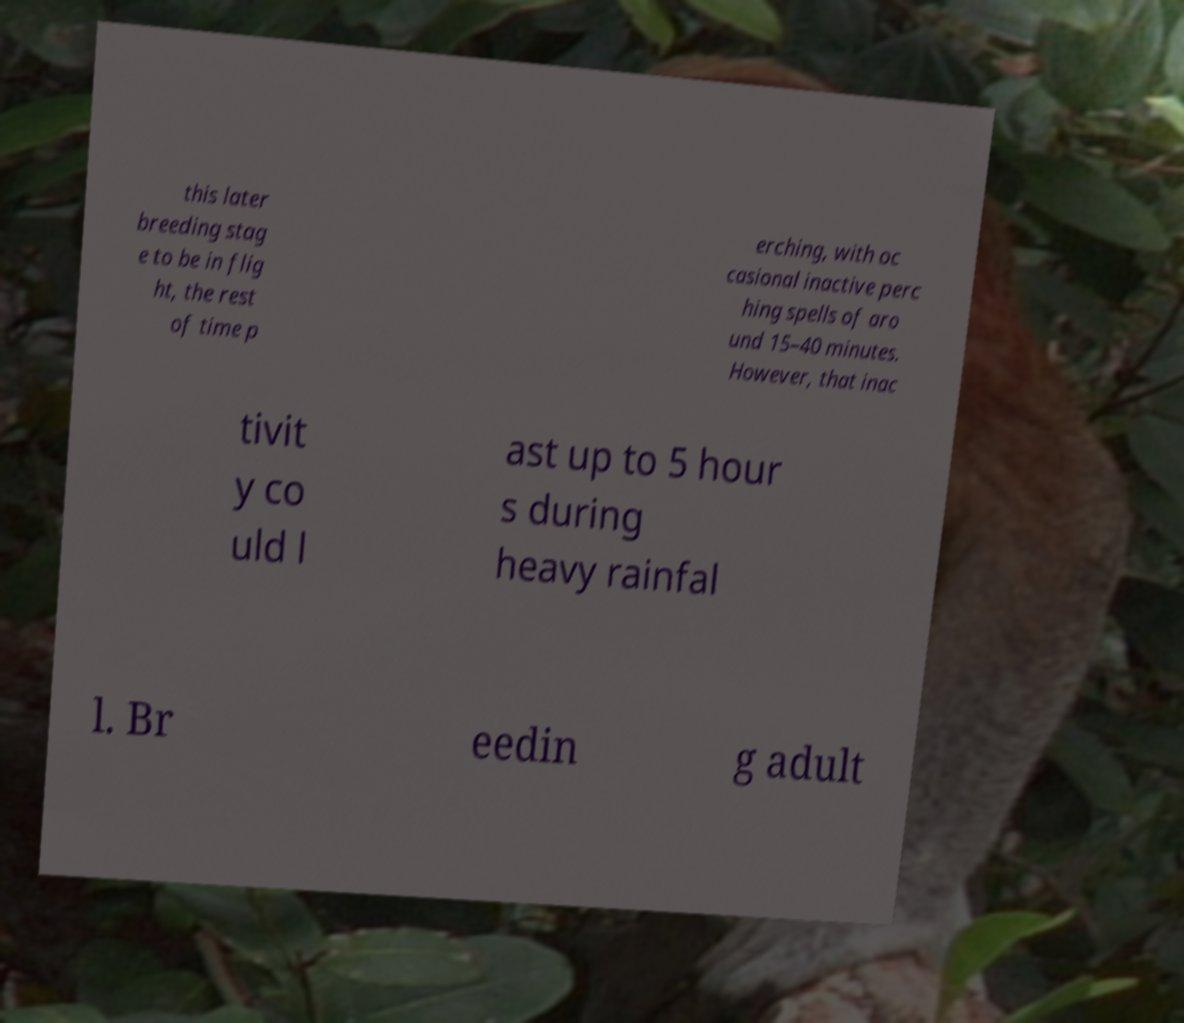Could you assist in decoding the text presented in this image and type it out clearly? this later breeding stag e to be in flig ht, the rest of time p erching, with oc casional inactive perc hing spells of aro und 15–40 minutes. However, that inac tivit y co uld l ast up to 5 hour s during heavy rainfal l. Br eedin g adult 